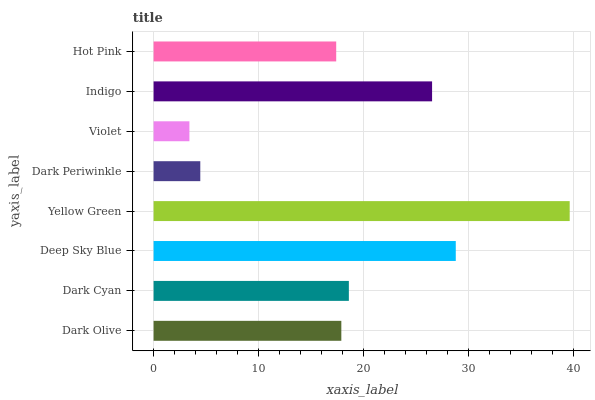Is Violet the minimum?
Answer yes or no. Yes. Is Yellow Green the maximum?
Answer yes or no. Yes. Is Dark Cyan the minimum?
Answer yes or no. No. Is Dark Cyan the maximum?
Answer yes or no. No. Is Dark Cyan greater than Dark Olive?
Answer yes or no. Yes. Is Dark Olive less than Dark Cyan?
Answer yes or no. Yes. Is Dark Olive greater than Dark Cyan?
Answer yes or no. No. Is Dark Cyan less than Dark Olive?
Answer yes or no. No. Is Dark Cyan the high median?
Answer yes or no. Yes. Is Dark Olive the low median?
Answer yes or no. Yes. Is Violet the high median?
Answer yes or no. No. Is Dark Cyan the low median?
Answer yes or no. No. 